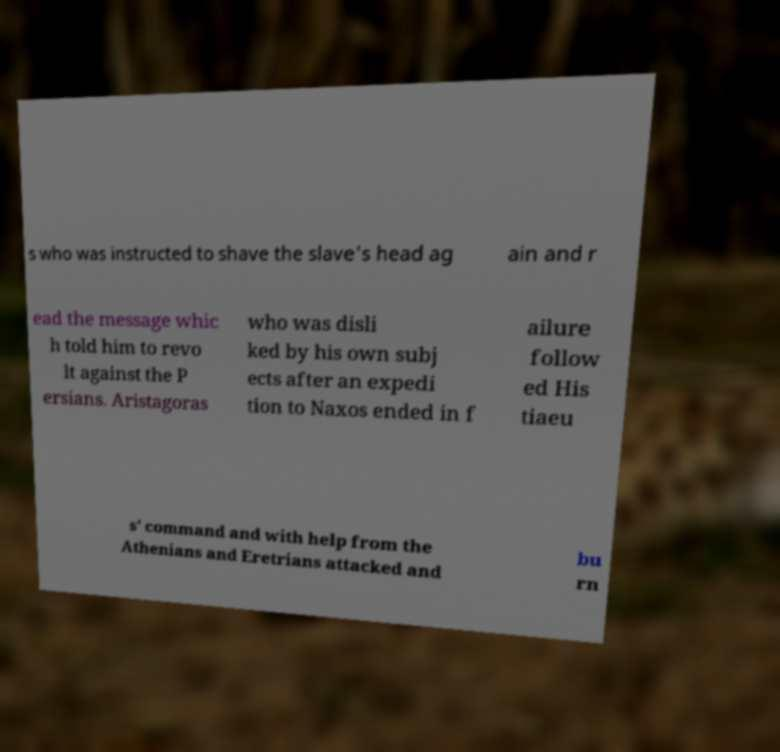For documentation purposes, I need the text within this image transcribed. Could you provide that? s who was instructed to shave the slave's head ag ain and r ead the message whic h told him to revo lt against the P ersians. Aristagoras who was disli ked by his own subj ects after an expedi tion to Naxos ended in f ailure follow ed His tiaeu s' command and with help from the Athenians and Eretrians attacked and bu rn 